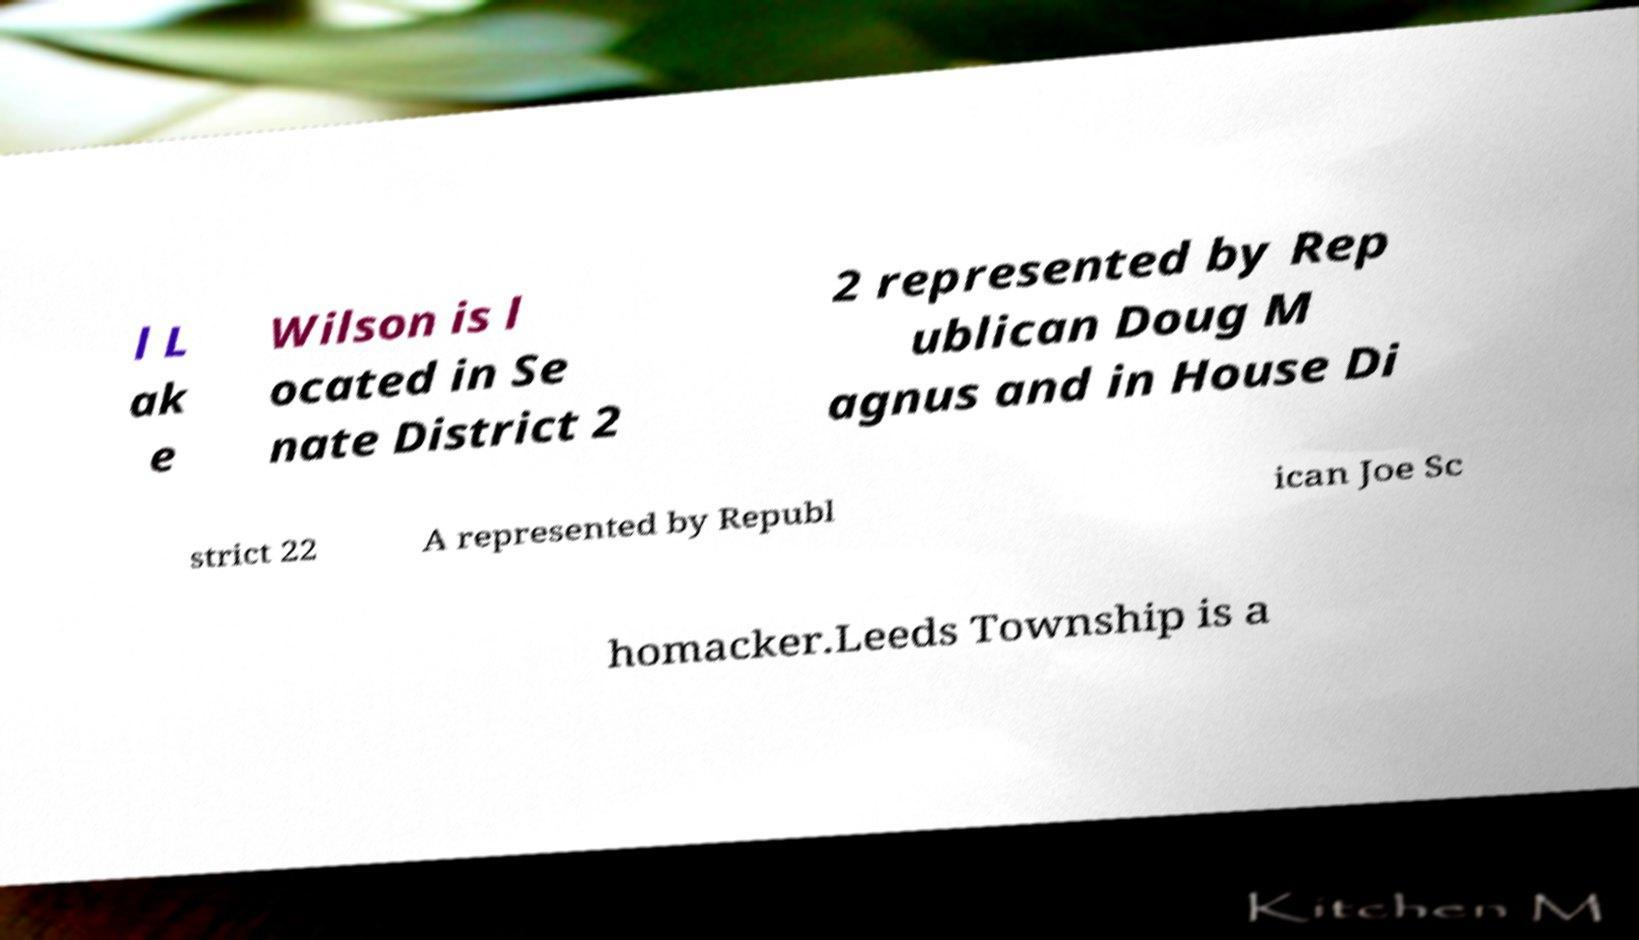Can you accurately transcribe the text from the provided image for me? l L ak e Wilson is l ocated in Se nate District 2 2 represented by Rep ublican Doug M agnus and in House Di strict 22 A represented by Republ ican Joe Sc homacker.Leeds Township is a 